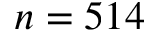Convert formula to latex. <formula><loc_0><loc_0><loc_500><loc_500>n = 5 1 4</formula> 